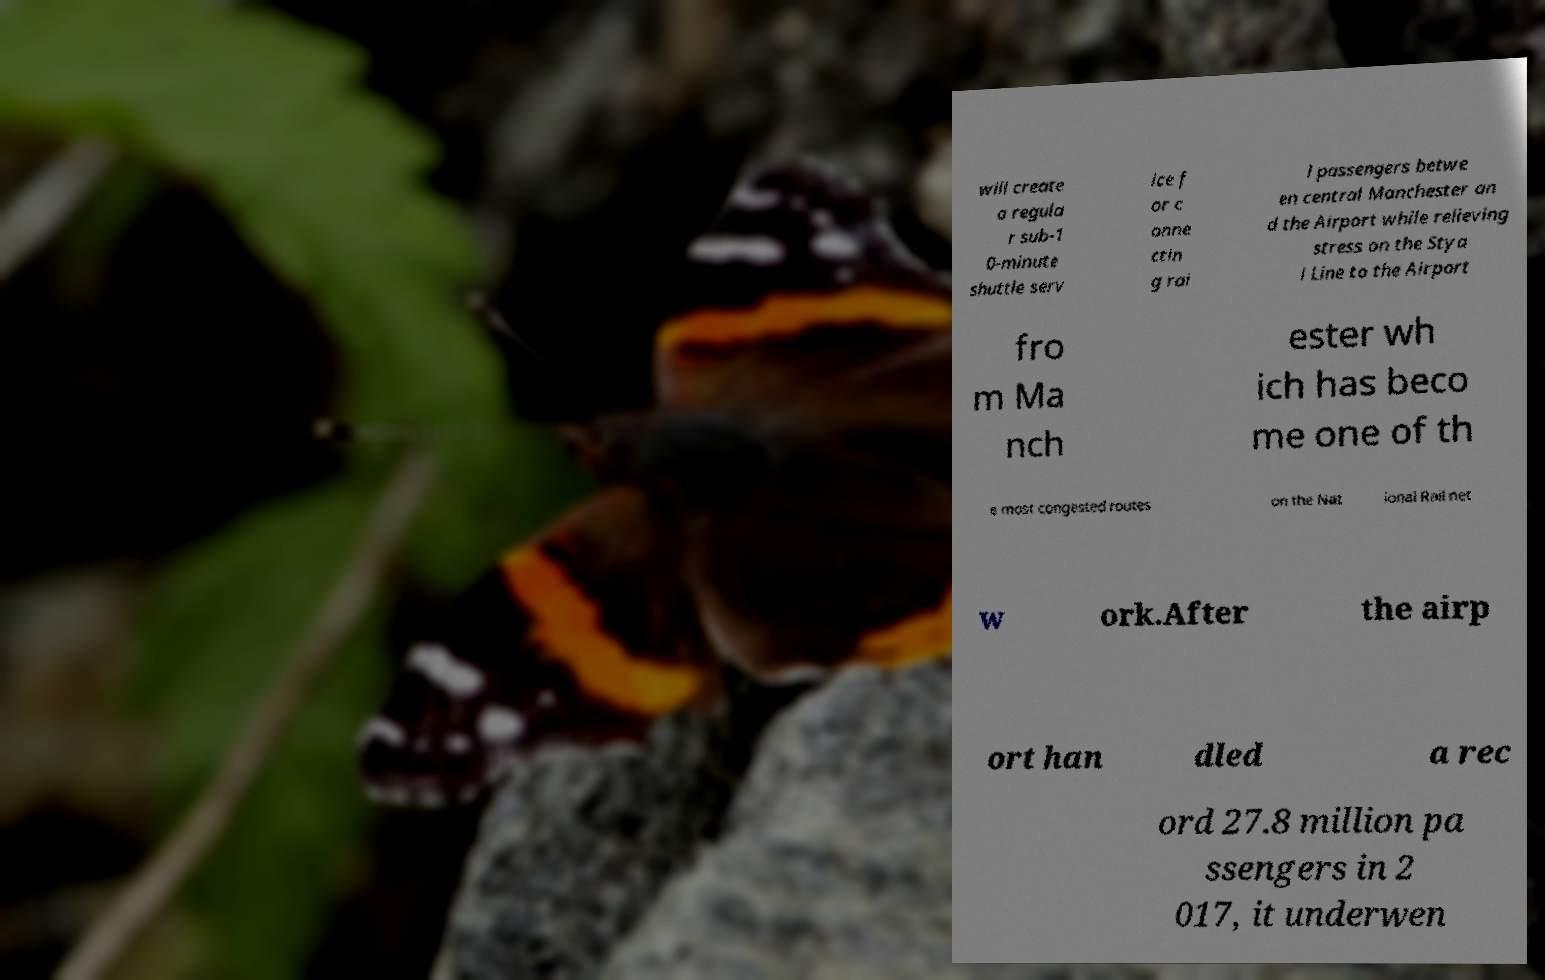Can you accurately transcribe the text from the provided image for me? will create a regula r sub-1 0-minute shuttle serv ice f or c onne ctin g rai l passengers betwe en central Manchester an d the Airport while relieving stress on the Stya l Line to the Airport fro m Ma nch ester wh ich has beco me one of th e most congested routes on the Nat ional Rail net w ork.After the airp ort han dled a rec ord 27.8 million pa ssengers in 2 017, it underwen 